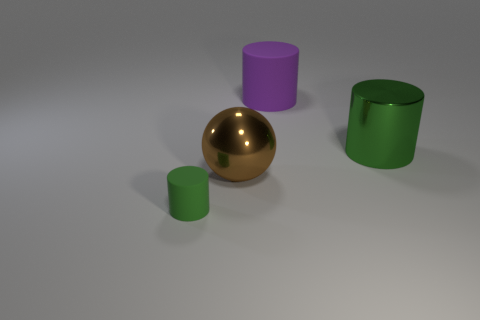Subtract all green cylinders. How many cylinders are left? 1 Subtract all cyan blocks. How many green cylinders are left? 2 Add 4 green objects. How many objects exist? 8 Add 4 green metal things. How many green metal things exist? 5 Subtract 0 green spheres. How many objects are left? 4 Subtract all spheres. How many objects are left? 3 Subtract all purple cylinders. Subtract all green balls. How many cylinders are left? 2 Subtract all tiny green things. Subtract all matte cylinders. How many objects are left? 1 Add 2 purple rubber cylinders. How many purple rubber cylinders are left? 3 